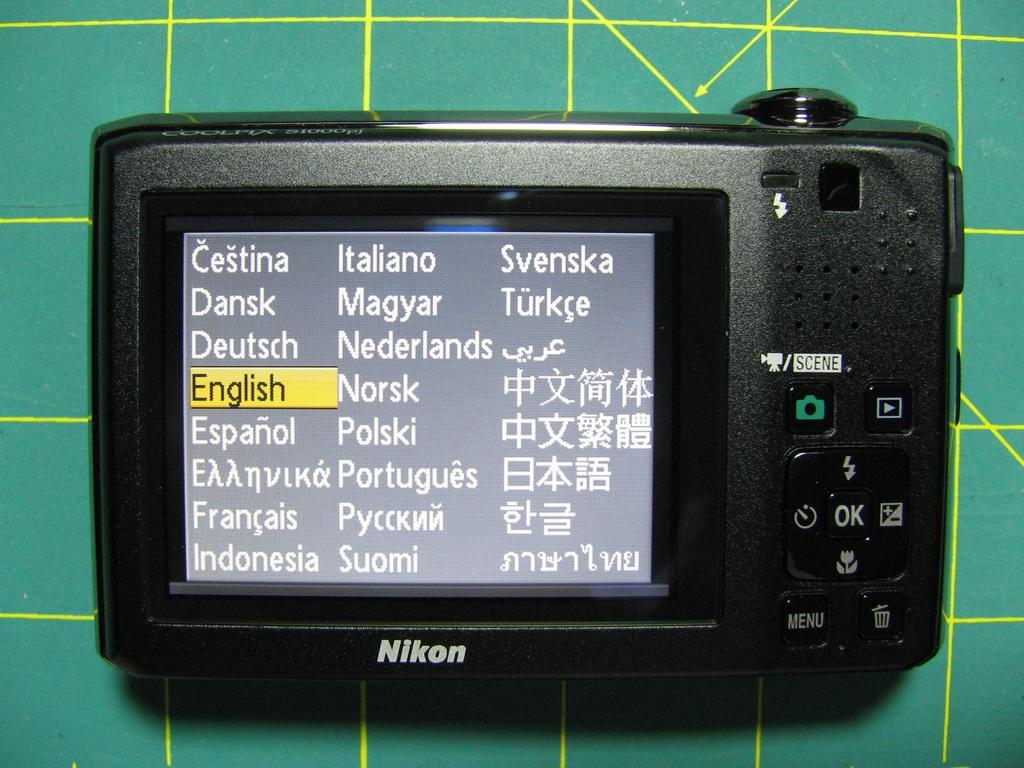Describe this image in one or two sentences. This image consists of a camera in black color. In the front, we can see a screen. It is kept on a desk, which is in green color. 